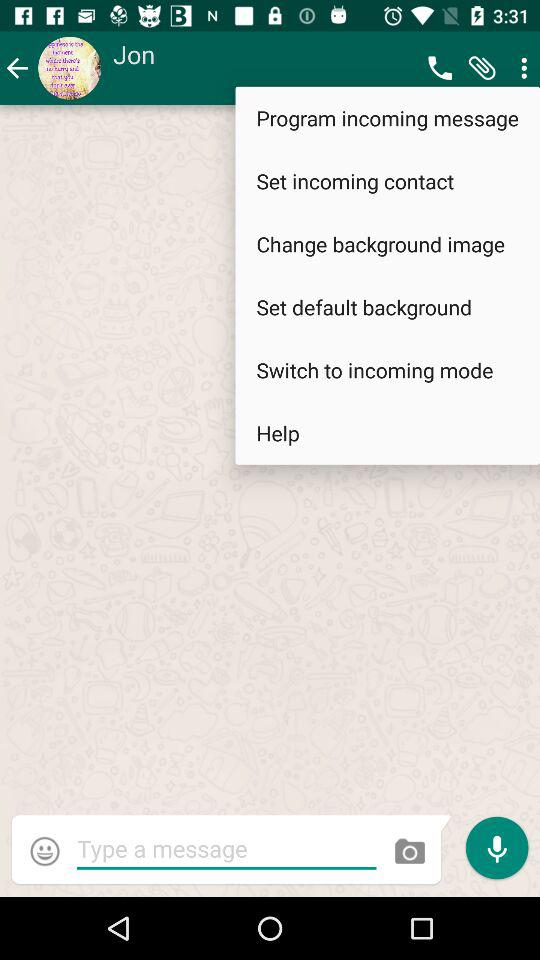What is the name of the user? The name of the user is Jon. 